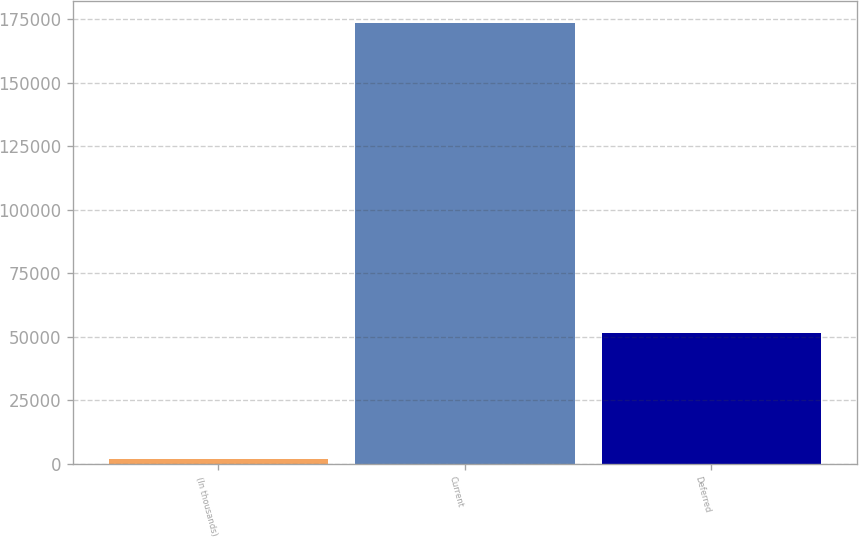<chart> <loc_0><loc_0><loc_500><loc_500><bar_chart><fcel>(In thousands)<fcel>Current<fcel>Deferred<nl><fcel>2013<fcel>173418<fcel>51475<nl></chart> 